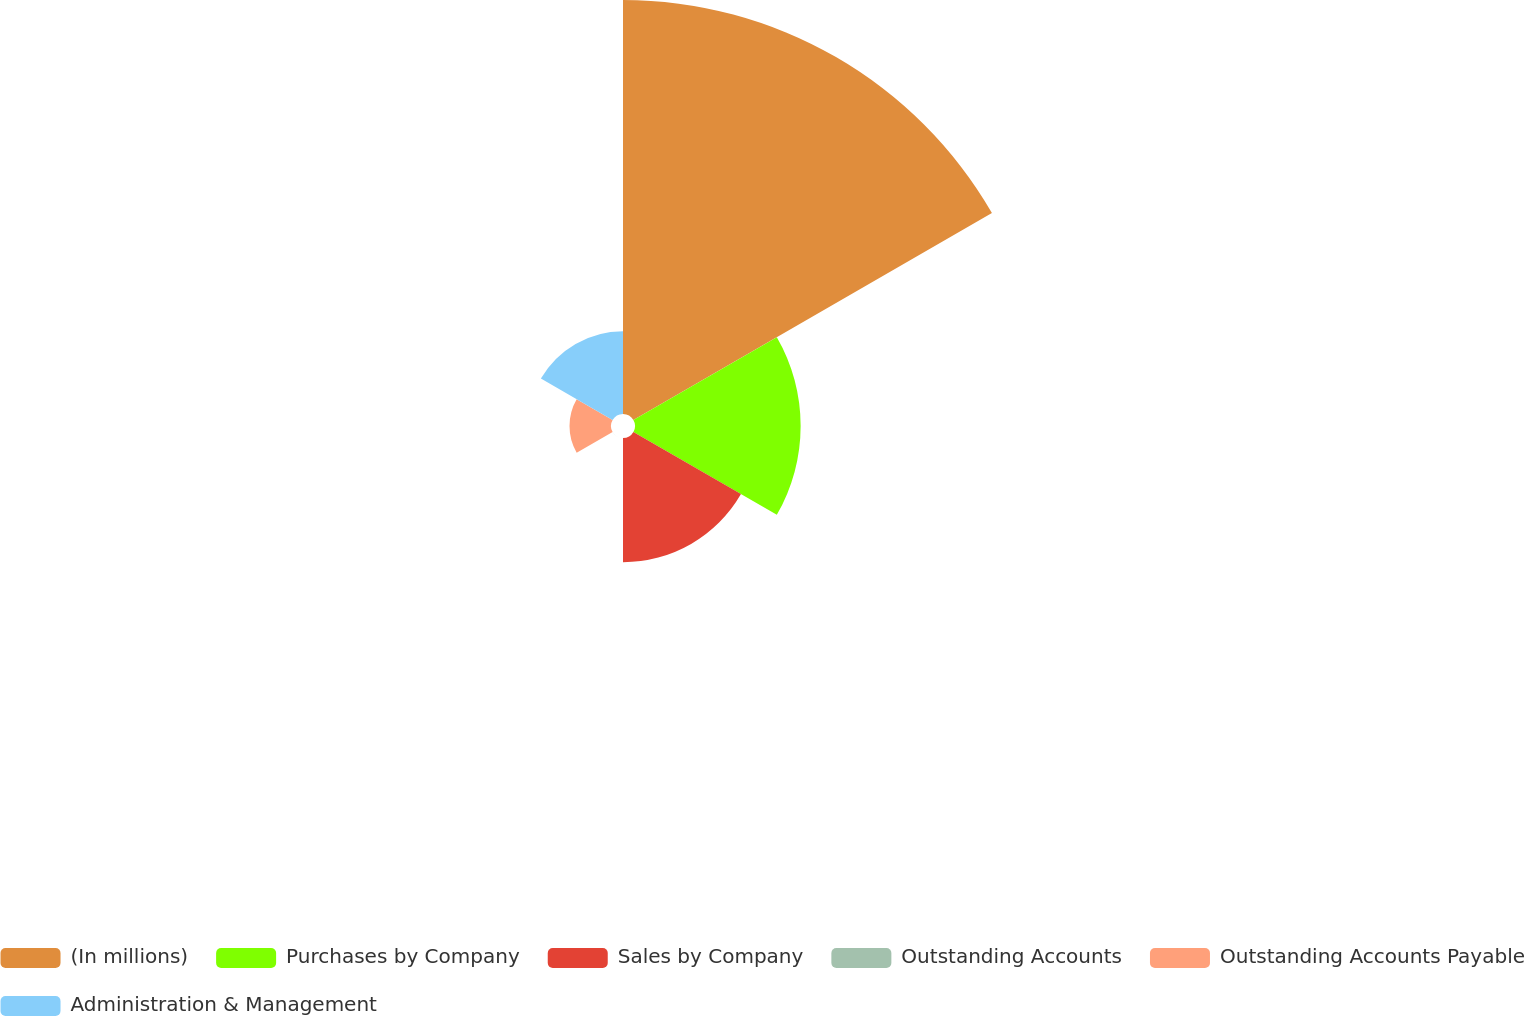Convert chart. <chart><loc_0><loc_0><loc_500><loc_500><pie_chart><fcel>(In millions)<fcel>Purchases by Company<fcel>Sales by Company<fcel>Outstanding Accounts<fcel>Outstanding Accounts Payable<fcel>Administration & Management<nl><fcel>49.99%<fcel>20.0%<fcel>15.0%<fcel>0.01%<fcel>5.01%<fcel>10.0%<nl></chart> 